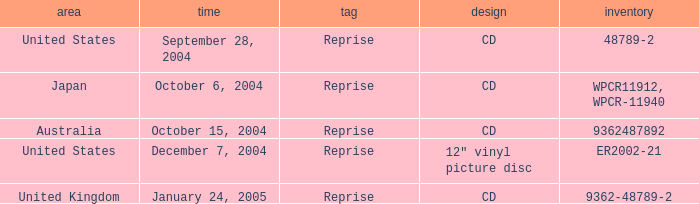Name the label for january 24, 2005 Reprise. 